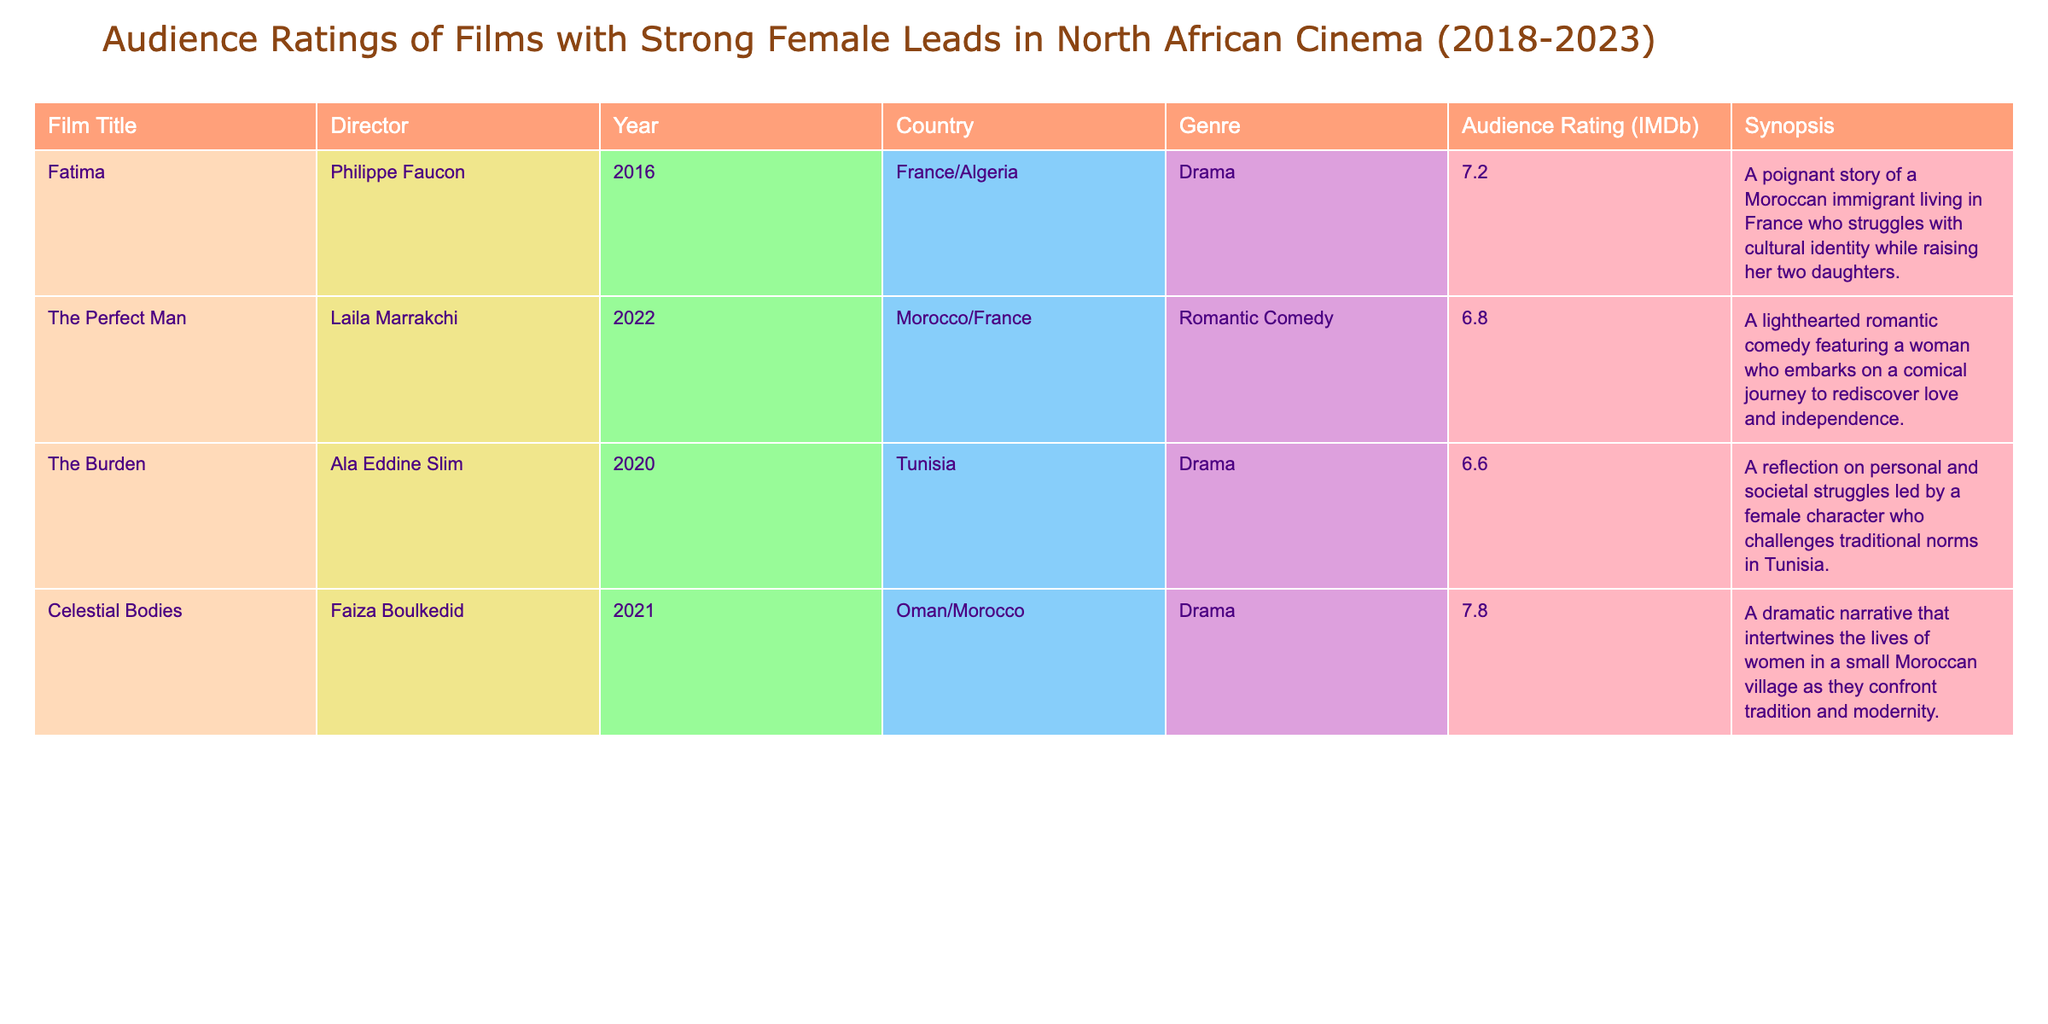What is the highest audience rating among the films listed? By examining the "Audience Rating (IMDb)" column, the highest value is 7.8, which corresponds to the film "Celestial Bodies."
Answer: 7.8 Which film has the lowest audience rating? Looking at the "Audience Rating (IMDb)" column, the lowest rating is 6.6, associated with the film "The Burden."
Answer: 6.6 How many films have an audience rating above 7? The films with ratings above 7 are "Fatima" (7.2) and "Celestial Bodies" (7.8). There are a total of 2 films.
Answer: 2 What is the average audience rating of the films listed? To find the average, sum the ratings: 7.2 + 6.8 + 6.6 + 7.8 = 28.4. Divide by the number of films (4) to get 28.4/4 = 7.1.
Answer: 7.1 Is "The Perfect Man" rated higher than "The Burden"? "The Perfect Man" has a rating of 6.8, while "The Burden" has a rating of 6.6. Since 6.8 is greater than 6.6, the statement is true.
Answer: Yes Identify the genre of the film with the highest rating. The film with the highest rating is "Celestial Bodies," which is categorized as a Drama.
Answer: Drama Are there more Romantic Comedies or Dramas in this table? The table contains 1 Romantic Comedy ("The Perfect Man") and 3 Dramas ("Fatima," "The Burden," and "Celestial Bodies"). Since 3 is greater than 1, Dramas outnumber Romantic Comedies.
Answer: Dramas Which country produced the film with the lowest audience rating? The film "The Burden," which has the lowest rating of 6.6, was produced in Tunisia.
Answer: Tunisia What is the difference between the highest and lowest audience ratings? The highest rating is 7.8 (from "Celestial Bodies"), and the lowest is 6.6 (from "The Burden"). Thus, the difference is 7.8 - 6.6 = 1.2.
Answer: 1.2 How many films are directed by Moroccan directors according to the table? The films directed by Moroccan directors are "The Perfect Man" and "Fatima." This totals 2 films.
Answer: 2 